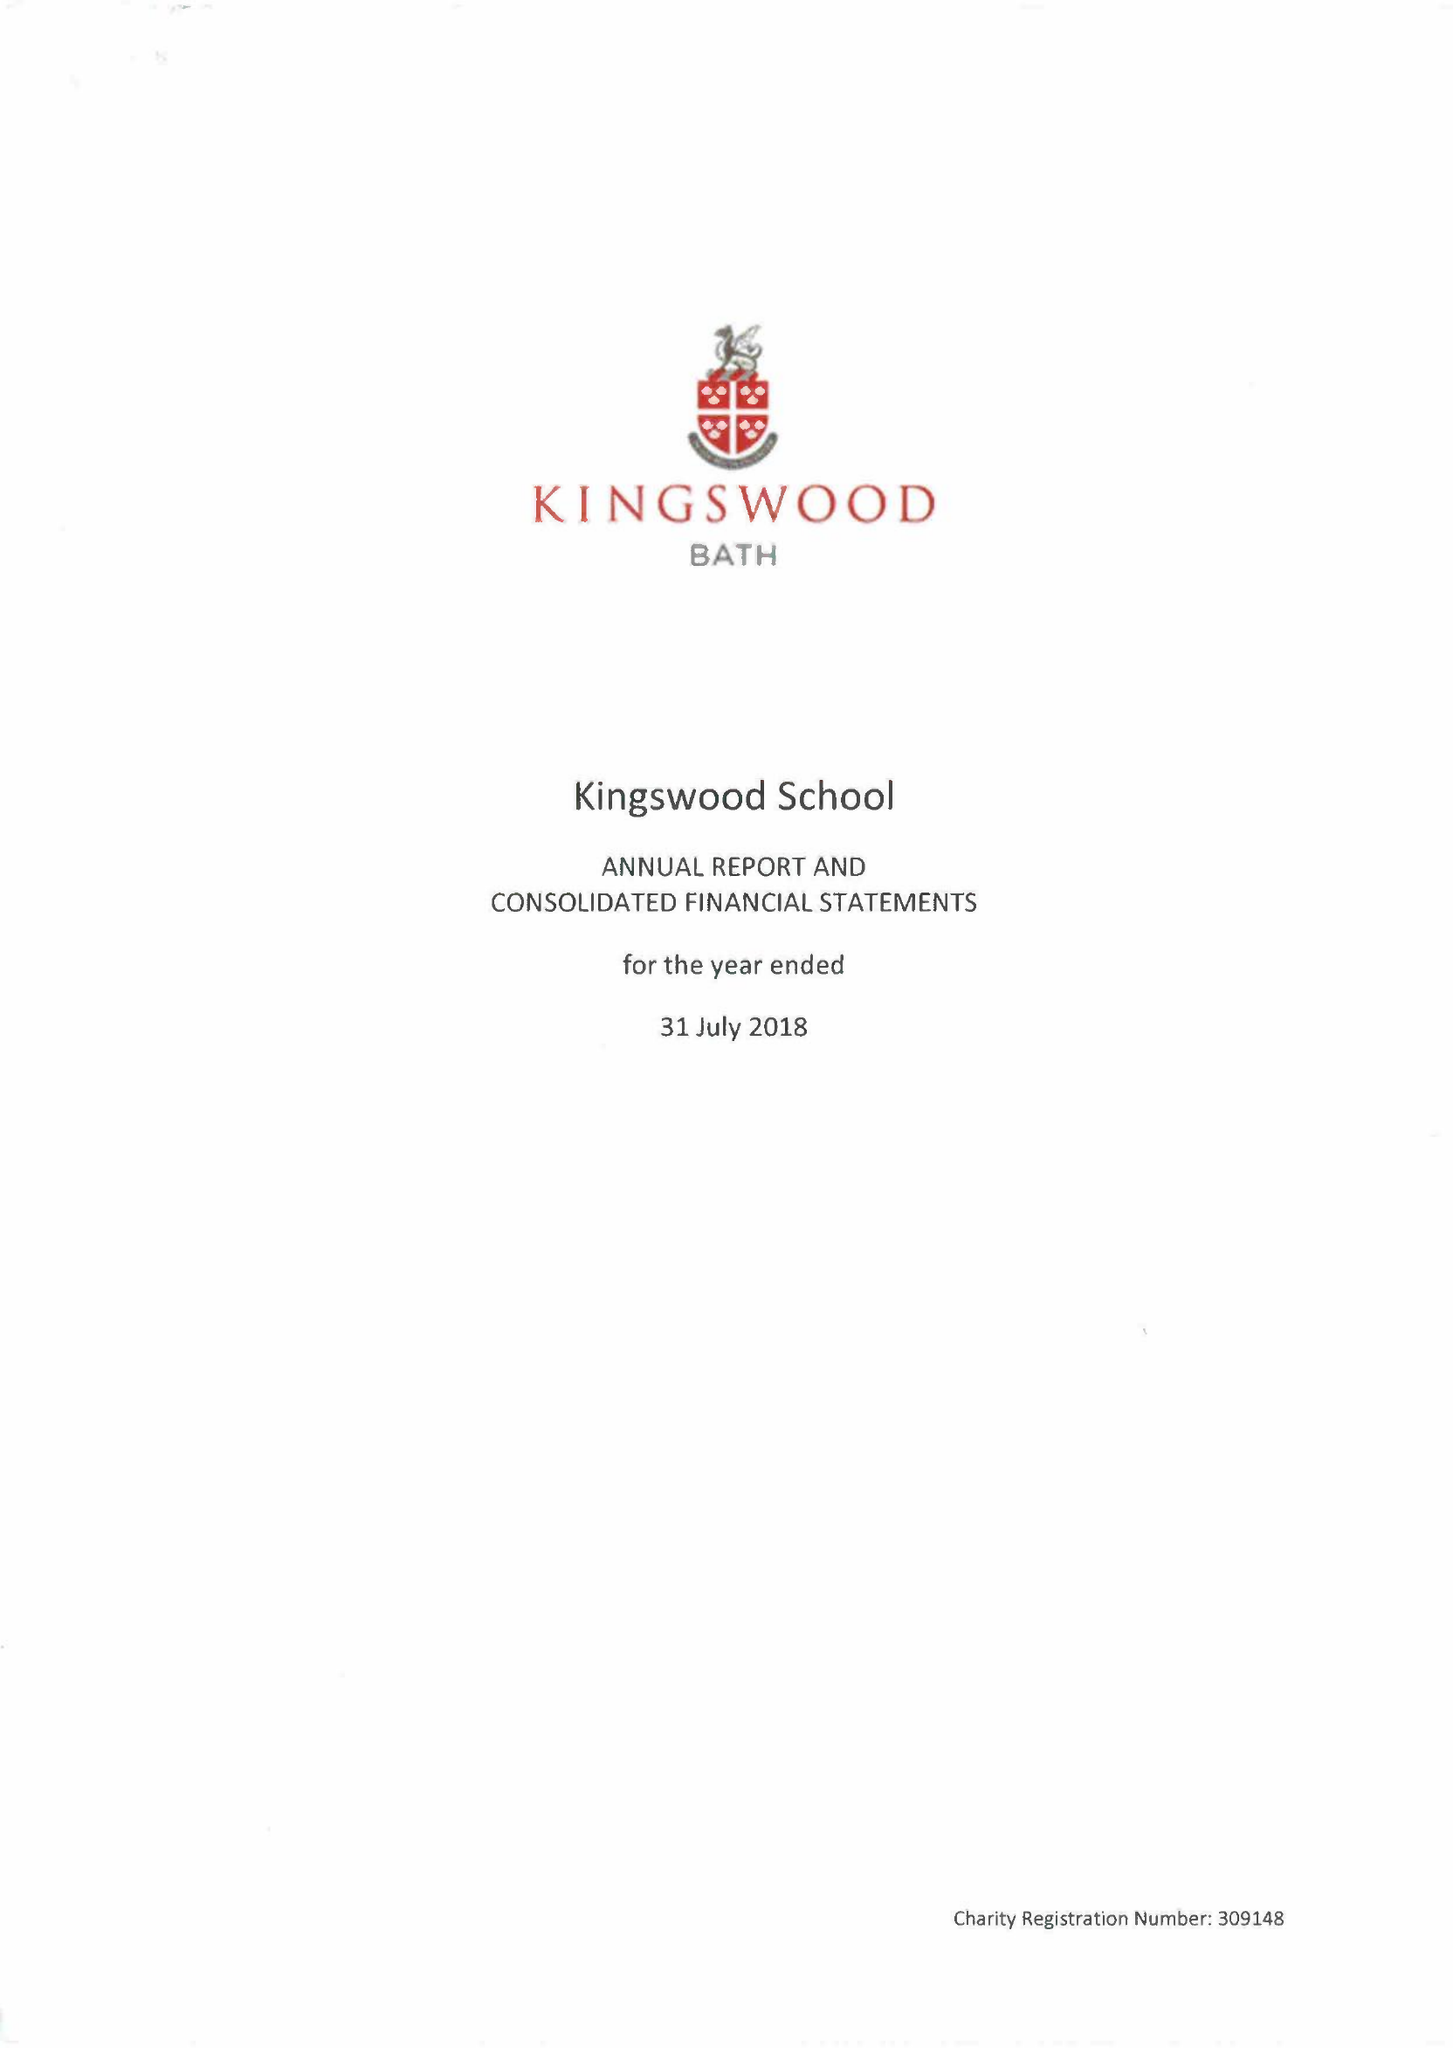What is the value for the address__post_town?
Answer the question using a single word or phrase. BATH 